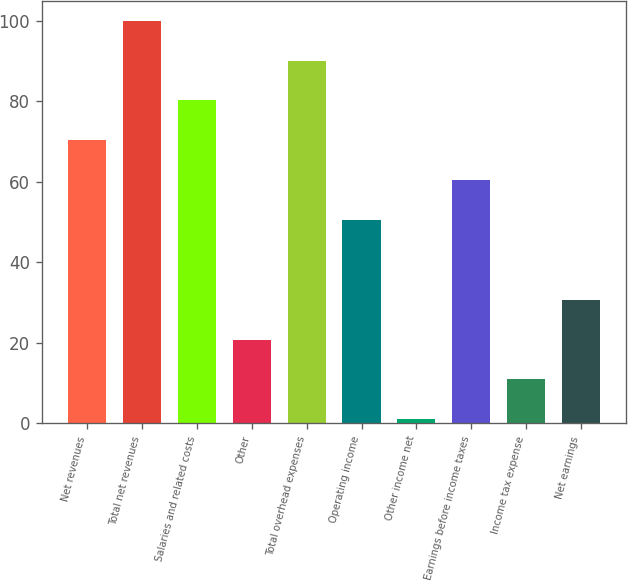Convert chart. <chart><loc_0><loc_0><loc_500><loc_500><bar_chart><fcel>Net revenues<fcel>Total net revenues<fcel>Salaries and related costs<fcel>Other<fcel>Total overhead expenses<fcel>Operating income<fcel>Other income net<fcel>Earnings before income taxes<fcel>Income tax expense<fcel>Net earnings<nl><fcel>70.3<fcel>100<fcel>80.2<fcel>20.8<fcel>90.1<fcel>50.5<fcel>1<fcel>60.4<fcel>10.9<fcel>30.7<nl></chart> 